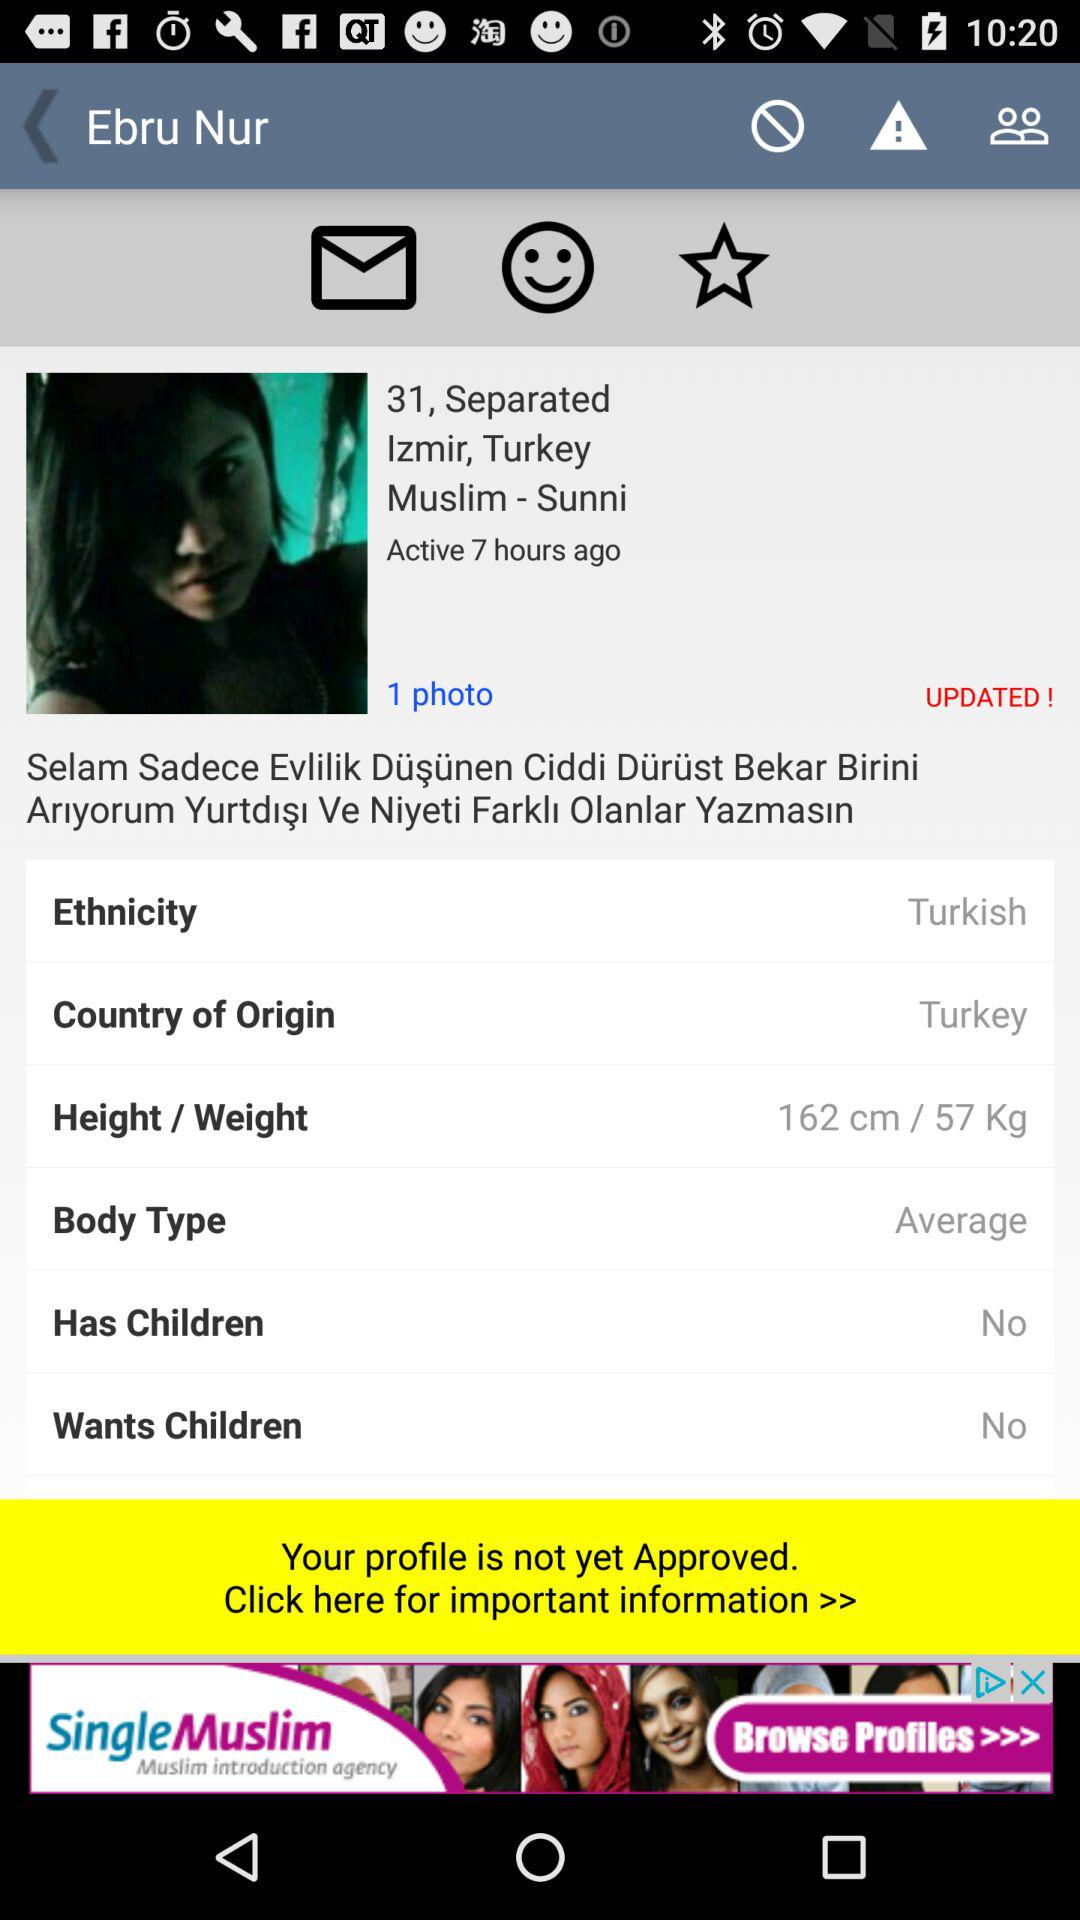What is the age of Ebru Nur? The age of Ebru Nur is 31 years old. 